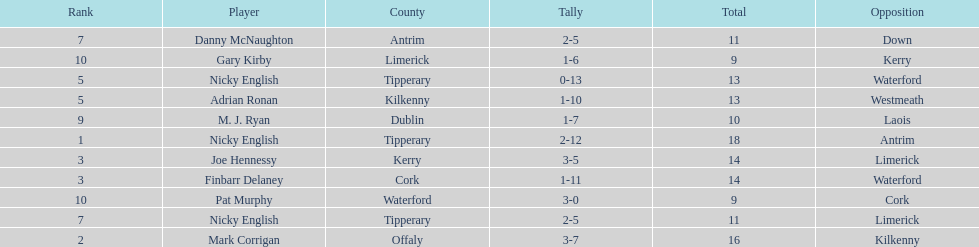How many people are on the list? 9. 